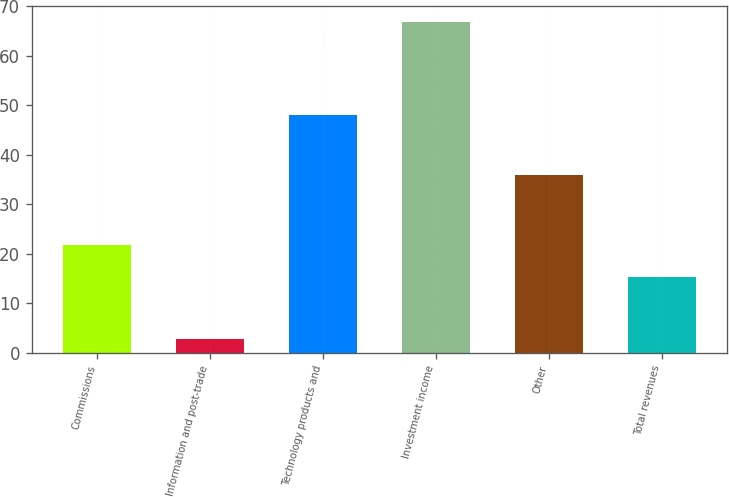Convert chart. <chart><loc_0><loc_0><loc_500><loc_500><bar_chart><fcel>Commissions<fcel>Information and post-trade<fcel>Technology products and<fcel>Investment income<fcel>Other<fcel>Total revenues<nl><fcel>21.7<fcel>2.7<fcel>48<fcel>66.7<fcel>35.8<fcel>15.3<nl></chart> 